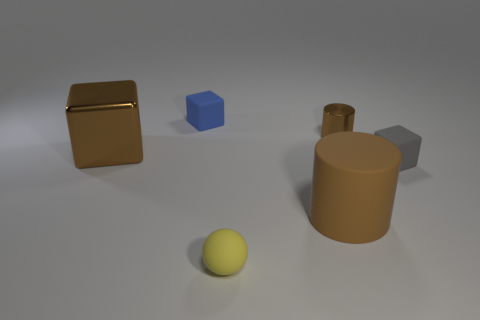Add 1 small yellow metallic cubes. How many objects exist? 7 Subtract all cylinders. How many objects are left? 4 Add 6 big shiny cubes. How many big shiny cubes are left? 7 Add 3 big cyan matte cylinders. How many big cyan matte cylinders exist? 3 Subtract 0 red cylinders. How many objects are left? 6 Subtract all rubber objects. Subtract all brown rubber cylinders. How many objects are left? 1 